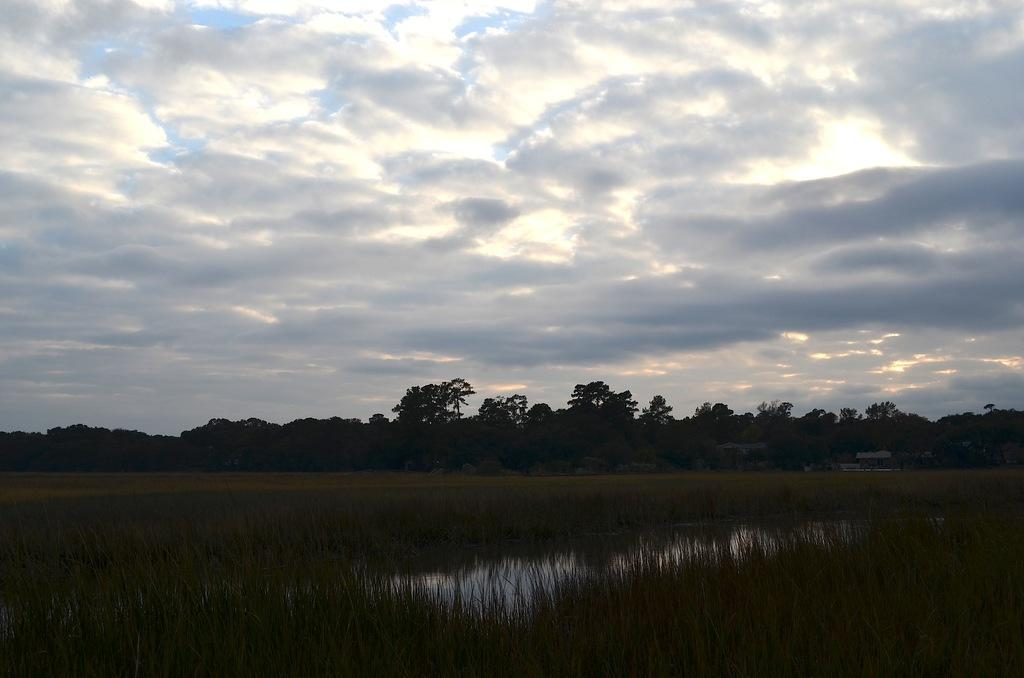What type of natural elements are present in the image? There are many trees and plants in the image. What else can be seen in the image besides trees and plants? There is water visible in the image, as well as houses. How would you describe the sky in the image? The sky is cloudy in the image. What type of pencil is being used to draw the houses in the image? There is no pencil or drawing activity present in the image; it is a photograph or illustration of real trees, plants, water, houses, and a cloudy sky. 